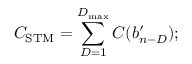Convert formula to latex. <formula><loc_0><loc_0><loc_500><loc_500>C _ { S T M } = \sum _ { D = 1 } ^ { D _ { \max } } C ( b _ { n - D } ^ { \prime } ) ;</formula> 